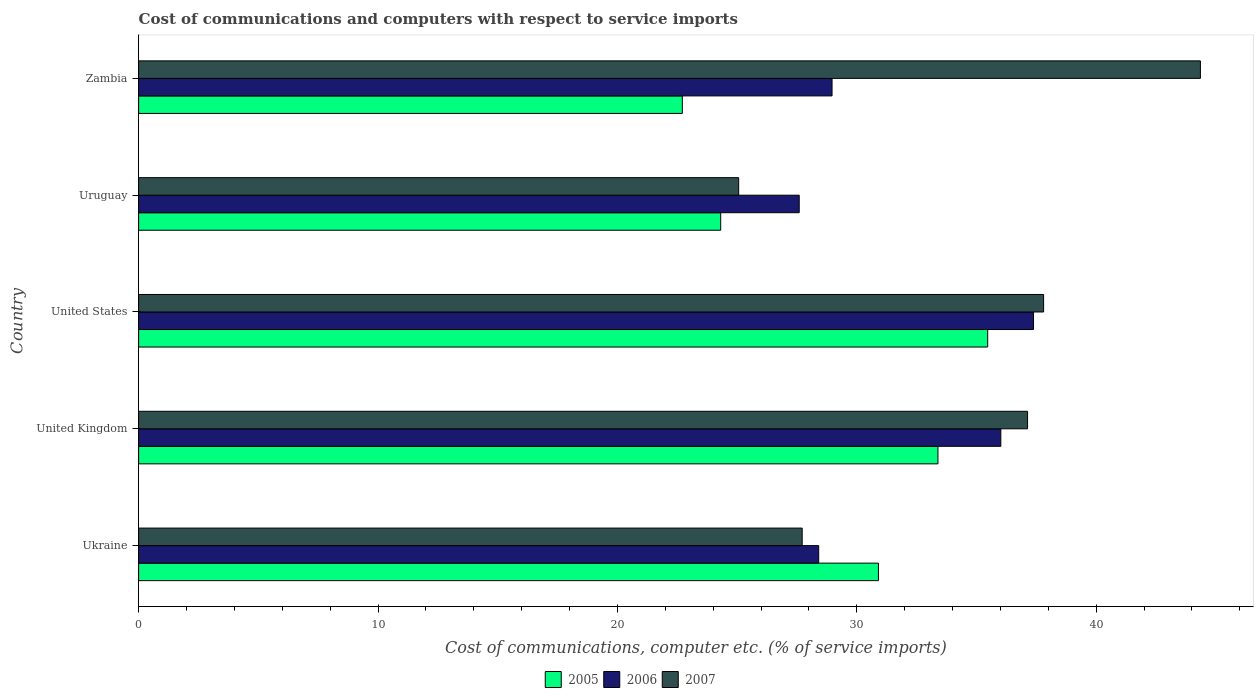Are the number of bars per tick equal to the number of legend labels?
Your response must be concise. Yes. Are the number of bars on each tick of the Y-axis equal?
Ensure brevity in your answer.  Yes. How many bars are there on the 3rd tick from the top?
Provide a succinct answer. 3. How many bars are there on the 1st tick from the bottom?
Your answer should be very brief. 3. What is the label of the 1st group of bars from the top?
Offer a terse response. Zambia. In how many cases, is the number of bars for a given country not equal to the number of legend labels?
Provide a short and direct response. 0. What is the cost of communications and computers in 2006 in United Kingdom?
Make the answer very short. 36.02. Across all countries, what is the maximum cost of communications and computers in 2005?
Offer a terse response. 35.47. Across all countries, what is the minimum cost of communications and computers in 2006?
Your response must be concise. 27.6. In which country was the cost of communications and computers in 2007 maximum?
Your response must be concise. Zambia. In which country was the cost of communications and computers in 2007 minimum?
Offer a terse response. Uruguay. What is the total cost of communications and computers in 2007 in the graph?
Your answer should be compact. 172.08. What is the difference between the cost of communications and computers in 2005 in United Kingdom and that in Zambia?
Provide a succinct answer. 10.68. What is the difference between the cost of communications and computers in 2005 in United Kingdom and the cost of communications and computers in 2006 in Ukraine?
Your answer should be compact. 4.98. What is the average cost of communications and computers in 2007 per country?
Your response must be concise. 34.42. What is the difference between the cost of communications and computers in 2007 and cost of communications and computers in 2006 in United States?
Ensure brevity in your answer.  0.42. What is the ratio of the cost of communications and computers in 2006 in United States to that in Zambia?
Make the answer very short. 1.29. Is the cost of communications and computers in 2005 in Ukraine less than that in United States?
Keep it short and to the point. Yes. What is the difference between the highest and the second highest cost of communications and computers in 2006?
Your response must be concise. 1.37. What is the difference between the highest and the lowest cost of communications and computers in 2007?
Provide a short and direct response. 19.29. In how many countries, is the cost of communications and computers in 2007 greater than the average cost of communications and computers in 2007 taken over all countries?
Offer a terse response. 3. What does the 1st bar from the top in Zambia represents?
Your answer should be compact. 2007. What does the 2nd bar from the bottom in Uruguay represents?
Your answer should be very brief. 2006. How many bars are there?
Make the answer very short. 15. Are all the bars in the graph horizontal?
Your answer should be very brief. Yes. What is the difference between two consecutive major ticks on the X-axis?
Your answer should be compact. 10. Does the graph contain any zero values?
Keep it short and to the point. No. Does the graph contain grids?
Your response must be concise. No. How are the legend labels stacked?
Keep it short and to the point. Horizontal. What is the title of the graph?
Provide a short and direct response. Cost of communications and computers with respect to service imports. What is the label or title of the X-axis?
Make the answer very short. Cost of communications, computer etc. (% of service imports). What is the Cost of communications, computer etc. (% of service imports) in 2005 in Ukraine?
Provide a succinct answer. 30.9. What is the Cost of communications, computer etc. (% of service imports) in 2006 in Ukraine?
Ensure brevity in your answer.  28.41. What is the Cost of communications, computer etc. (% of service imports) in 2007 in Ukraine?
Offer a very short reply. 27.72. What is the Cost of communications, computer etc. (% of service imports) in 2005 in United Kingdom?
Keep it short and to the point. 33.39. What is the Cost of communications, computer etc. (% of service imports) in 2006 in United Kingdom?
Your response must be concise. 36.02. What is the Cost of communications, computer etc. (% of service imports) in 2007 in United Kingdom?
Offer a terse response. 37.13. What is the Cost of communications, computer etc. (% of service imports) of 2005 in United States?
Make the answer very short. 35.47. What is the Cost of communications, computer etc. (% of service imports) of 2006 in United States?
Your answer should be compact. 37.38. What is the Cost of communications, computer etc. (% of service imports) of 2007 in United States?
Your answer should be very brief. 37.8. What is the Cost of communications, computer etc. (% of service imports) in 2005 in Uruguay?
Your response must be concise. 24.32. What is the Cost of communications, computer etc. (% of service imports) of 2006 in Uruguay?
Your answer should be very brief. 27.6. What is the Cost of communications, computer etc. (% of service imports) of 2007 in Uruguay?
Your response must be concise. 25.07. What is the Cost of communications, computer etc. (% of service imports) in 2005 in Zambia?
Provide a short and direct response. 22.71. What is the Cost of communications, computer etc. (% of service imports) of 2006 in Zambia?
Offer a terse response. 28.97. What is the Cost of communications, computer etc. (% of service imports) in 2007 in Zambia?
Your response must be concise. 44.35. Across all countries, what is the maximum Cost of communications, computer etc. (% of service imports) of 2005?
Provide a short and direct response. 35.47. Across all countries, what is the maximum Cost of communications, computer etc. (% of service imports) in 2006?
Offer a very short reply. 37.38. Across all countries, what is the maximum Cost of communications, computer etc. (% of service imports) of 2007?
Give a very brief answer. 44.35. Across all countries, what is the minimum Cost of communications, computer etc. (% of service imports) of 2005?
Your response must be concise. 22.71. Across all countries, what is the minimum Cost of communications, computer etc. (% of service imports) of 2006?
Provide a short and direct response. 27.6. Across all countries, what is the minimum Cost of communications, computer etc. (% of service imports) in 2007?
Your answer should be compact. 25.07. What is the total Cost of communications, computer etc. (% of service imports) in 2005 in the graph?
Your answer should be very brief. 146.79. What is the total Cost of communications, computer etc. (% of service imports) in 2006 in the graph?
Your answer should be compact. 158.37. What is the total Cost of communications, computer etc. (% of service imports) in 2007 in the graph?
Your answer should be compact. 172.08. What is the difference between the Cost of communications, computer etc. (% of service imports) of 2005 in Ukraine and that in United Kingdom?
Offer a very short reply. -2.49. What is the difference between the Cost of communications, computer etc. (% of service imports) of 2006 in Ukraine and that in United Kingdom?
Your response must be concise. -7.61. What is the difference between the Cost of communications, computer etc. (% of service imports) of 2007 in Ukraine and that in United Kingdom?
Your response must be concise. -9.41. What is the difference between the Cost of communications, computer etc. (% of service imports) in 2005 in Ukraine and that in United States?
Keep it short and to the point. -4.56. What is the difference between the Cost of communications, computer etc. (% of service imports) of 2006 in Ukraine and that in United States?
Your response must be concise. -8.97. What is the difference between the Cost of communications, computer etc. (% of service imports) in 2007 in Ukraine and that in United States?
Offer a very short reply. -10.09. What is the difference between the Cost of communications, computer etc. (% of service imports) of 2005 in Ukraine and that in Uruguay?
Provide a succinct answer. 6.59. What is the difference between the Cost of communications, computer etc. (% of service imports) of 2006 in Ukraine and that in Uruguay?
Provide a short and direct response. 0.81. What is the difference between the Cost of communications, computer etc. (% of service imports) of 2007 in Ukraine and that in Uruguay?
Give a very brief answer. 2.65. What is the difference between the Cost of communications, computer etc. (% of service imports) in 2005 in Ukraine and that in Zambia?
Offer a very short reply. 8.19. What is the difference between the Cost of communications, computer etc. (% of service imports) in 2006 in Ukraine and that in Zambia?
Make the answer very short. -0.56. What is the difference between the Cost of communications, computer etc. (% of service imports) in 2007 in Ukraine and that in Zambia?
Offer a terse response. -16.64. What is the difference between the Cost of communications, computer etc. (% of service imports) in 2005 in United Kingdom and that in United States?
Ensure brevity in your answer.  -2.08. What is the difference between the Cost of communications, computer etc. (% of service imports) of 2006 in United Kingdom and that in United States?
Provide a short and direct response. -1.37. What is the difference between the Cost of communications, computer etc. (% of service imports) of 2007 in United Kingdom and that in United States?
Offer a very short reply. -0.67. What is the difference between the Cost of communications, computer etc. (% of service imports) of 2005 in United Kingdom and that in Uruguay?
Offer a very short reply. 9.08. What is the difference between the Cost of communications, computer etc. (% of service imports) in 2006 in United Kingdom and that in Uruguay?
Your answer should be very brief. 8.42. What is the difference between the Cost of communications, computer etc. (% of service imports) of 2007 in United Kingdom and that in Uruguay?
Ensure brevity in your answer.  12.07. What is the difference between the Cost of communications, computer etc. (% of service imports) of 2005 in United Kingdom and that in Zambia?
Offer a very short reply. 10.68. What is the difference between the Cost of communications, computer etc. (% of service imports) of 2006 in United Kingdom and that in Zambia?
Ensure brevity in your answer.  7.05. What is the difference between the Cost of communications, computer etc. (% of service imports) of 2007 in United Kingdom and that in Zambia?
Your answer should be compact. -7.22. What is the difference between the Cost of communications, computer etc. (% of service imports) of 2005 in United States and that in Uruguay?
Your answer should be very brief. 11.15. What is the difference between the Cost of communications, computer etc. (% of service imports) of 2006 in United States and that in Uruguay?
Keep it short and to the point. 9.79. What is the difference between the Cost of communications, computer etc. (% of service imports) of 2007 in United States and that in Uruguay?
Provide a succinct answer. 12.74. What is the difference between the Cost of communications, computer etc. (% of service imports) in 2005 in United States and that in Zambia?
Your answer should be compact. 12.76. What is the difference between the Cost of communications, computer etc. (% of service imports) of 2006 in United States and that in Zambia?
Make the answer very short. 8.42. What is the difference between the Cost of communications, computer etc. (% of service imports) of 2007 in United States and that in Zambia?
Offer a terse response. -6.55. What is the difference between the Cost of communications, computer etc. (% of service imports) of 2005 in Uruguay and that in Zambia?
Provide a short and direct response. 1.6. What is the difference between the Cost of communications, computer etc. (% of service imports) in 2006 in Uruguay and that in Zambia?
Your response must be concise. -1.37. What is the difference between the Cost of communications, computer etc. (% of service imports) of 2007 in Uruguay and that in Zambia?
Provide a short and direct response. -19.29. What is the difference between the Cost of communications, computer etc. (% of service imports) in 2005 in Ukraine and the Cost of communications, computer etc. (% of service imports) in 2006 in United Kingdom?
Your answer should be compact. -5.11. What is the difference between the Cost of communications, computer etc. (% of service imports) in 2005 in Ukraine and the Cost of communications, computer etc. (% of service imports) in 2007 in United Kingdom?
Make the answer very short. -6.23. What is the difference between the Cost of communications, computer etc. (% of service imports) in 2006 in Ukraine and the Cost of communications, computer etc. (% of service imports) in 2007 in United Kingdom?
Offer a terse response. -8.72. What is the difference between the Cost of communications, computer etc. (% of service imports) of 2005 in Ukraine and the Cost of communications, computer etc. (% of service imports) of 2006 in United States?
Ensure brevity in your answer.  -6.48. What is the difference between the Cost of communications, computer etc. (% of service imports) in 2005 in Ukraine and the Cost of communications, computer etc. (% of service imports) in 2007 in United States?
Keep it short and to the point. -6.9. What is the difference between the Cost of communications, computer etc. (% of service imports) of 2006 in Ukraine and the Cost of communications, computer etc. (% of service imports) of 2007 in United States?
Provide a short and direct response. -9.4. What is the difference between the Cost of communications, computer etc. (% of service imports) of 2005 in Ukraine and the Cost of communications, computer etc. (% of service imports) of 2006 in Uruguay?
Ensure brevity in your answer.  3.31. What is the difference between the Cost of communications, computer etc. (% of service imports) in 2005 in Ukraine and the Cost of communications, computer etc. (% of service imports) in 2007 in Uruguay?
Keep it short and to the point. 5.84. What is the difference between the Cost of communications, computer etc. (% of service imports) of 2006 in Ukraine and the Cost of communications, computer etc. (% of service imports) of 2007 in Uruguay?
Make the answer very short. 3.34. What is the difference between the Cost of communications, computer etc. (% of service imports) in 2005 in Ukraine and the Cost of communications, computer etc. (% of service imports) in 2006 in Zambia?
Provide a short and direct response. 1.94. What is the difference between the Cost of communications, computer etc. (% of service imports) of 2005 in Ukraine and the Cost of communications, computer etc. (% of service imports) of 2007 in Zambia?
Provide a succinct answer. -13.45. What is the difference between the Cost of communications, computer etc. (% of service imports) in 2006 in Ukraine and the Cost of communications, computer etc. (% of service imports) in 2007 in Zambia?
Provide a short and direct response. -15.95. What is the difference between the Cost of communications, computer etc. (% of service imports) of 2005 in United Kingdom and the Cost of communications, computer etc. (% of service imports) of 2006 in United States?
Provide a succinct answer. -3.99. What is the difference between the Cost of communications, computer etc. (% of service imports) in 2005 in United Kingdom and the Cost of communications, computer etc. (% of service imports) in 2007 in United States?
Ensure brevity in your answer.  -4.41. What is the difference between the Cost of communications, computer etc. (% of service imports) in 2006 in United Kingdom and the Cost of communications, computer etc. (% of service imports) in 2007 in United States?
Keep it short and to the point. -1.79. What is the difference between the Cost of communications, computer etc. (% of service imports) of 2005 in United Kingdom and the Cost of communications, computer etc. (% of service imports) of 2006 in Uruguay?
Ensure brevity in your answer.  5.79. What is the difference between the Cost of communications, computer etc. (% of service imports) in 2005 in United Kingdom and the Cost of communications, computer etc. (% of service imports) in 2007 in Uruguay?
Your answer should be compact. 8.32. What is the difference between the Cost of communications, computer etc. (% of service imports) in 2006 in United Kingdom and the Cost of communications, computer etc. (% of service imports) in 2007 in Uruguay?
Keep it short and to the point. 10.95. What is the difference between the Cost of communications, computer etc. (% of service imports) in 2005 in United Kingdom and the Cost of communications, computer etc. (% of service imports) in 2006 in Zambia?
Provide a succinct answer. 4.42. What is the difference between the Cost of communications, computer etc. (% of service imports) in 2005 in United Kingdom and the Cost of communications, computer etc. (% of service imports) in 2007 in Zambia?
Give a very brief answer. -10.96. What is the difference between the Cost of communications, computer etc. (% of service imports) of 2006 in United Kingdom and the Cost of communications, computer etc. (% of service imports) of 2007 in Zambia?
Offer a very short reply. -8.34. What is the difference between the Cost of communications, computer etc. (% of service imports) in 2005 in United States and the Cost of communications, computer etc. (% of service imports) in 2006 in Uruguay?
Ensure brevity in your answer.  7.87. What is the difference between the Cost of communications, computer etc. (% of service imports) of 2005 in United States and the Cost of communications, computer etc. (% of service imports) of 2007 in Uruguay?
Give a very brief answer. 10.4. What is the difference between the Cost of communications, computer etc. (% of service imports) of 2006 in United States and the Cost of communications, computer etc. (% of service imports) of 2007 in Uruguay?
Keep it short and to the point. 12.32. What is the difference between the Cost of communications, computer etc. (% of service imports) of 2005 in United States and the Cost of communications, computer etc. (% of service imports) of 2006 in Zambia?
Your response must be concise. 6.5. What is the difference between the Cost of communications, computer etc. (% of service imports) in 2005 in United States and the Cost of communications, computer etc. (% of service imports) in 2007 in Zambia?
Offer a terse response. -8.89. What is the difference between the Cost of communications, computer etc. (% of service imports) in 2006 in United States and the Cost of communications, computer etc. (% of service imports) in 2007 in Zambia?
Offer a terse response. -6.97. What is the difference between the Cost of communications, computer etc. (% of service imports) of 2005 in Uruguay and the Cost of communications, computer etc. (% of service imports) of 2006 in Zambia?
Your response must be concise. -4.65. What is the difference between the Cost of communications, computer etc. (% of service imports) in 2005 in Uruguay and the Cost of communications, computer etc. (% of service imports) in 2007 in Zambia?
Your response must be concise. -20.04. What is the difference between the Cost of communications, computer etc. (% of service imports) in 2006 in Uruguay and the Cost of communications, computer etc. (% of service imports) in 2007 in Zambia?
Your answer should be compact. -16.76. What is the average Cost of communications, computer etc. (% of service imports) of 2005 per country?
Ensure brevity in your answer.  29.36. What is the average Cost of communications, computer etc. (% of service imports) of 2006 per country?
Your answer should be compact. 31.67. What is the average Cost of communications, computer etc. (% of service imports) of 2007 per country?
Give a very brief answer. 34.42. What is the difference between the Cost of communications, computer etc. (% of service imports) of 2005 and Cost of communications, computer etc. (% of service imports) of 2006 in Ukraine?
Provide a short and direct response. 2.5. What is the difference between the Cost of communications, computer etc. (% of service imports) of 2005 and Cost of communications, computer etc. (% of service imports) of 2007 in Ukraine?
Keep it short and to the point. 3.19. What is the difference between the Cost of communications, computer etc. (% of service imports) of 2006 and Cost of communications, computer etc. (% of service imports) of 2007 in Ukraine?
Offer a very short reply. 0.69. What is the difference between the Cost of communications, computer etc. (% of service imports) in 2005 and Cost of communications, computer etc. (% of service imports) in 2006 in United Kingdom?
Make the answer very short. -2.63. What is the difference between the Cost of communications, computer etc. (% of service imports) in 2005 and Cost of communications, computer etc. (% of service imports) in 2007 in United Kingdom?
Your answer should be very brief. -3.74. What is the difference between the Cost of communications, computer etc. (% of service imports) in 2006 and Cost of communications, computer etc. (% of service imports) in 2007 in United Kingdom?
Provide a short and direct response. -1.12. What is the difference between the Cost of communications, computer etc. (% of service imports) in 2005 and Cost of communications, computer etc. (% of service imports) in 2006 in United States?
Provide a short and direct response. -1.91. What is the difference between the Cost of communications, computer etc. (% of service imports) of 2005 and Cost of communications, computer etc. (% of service imports) of 2007 in United States?
Your answer should be compact. -2.34. What is the difference between the Cost of communications, computer etc. (% of service imports) in 2006 and Cost of communications, computer etc. (% of service imports) in 2007 in United States?
Your answer should be very brief. -0.42. What is the difference between the Cost of communications, computer etc. (% of service imports) of 2005 and Cost of communications, computer etc. (% of service imports) of 2006 in Uruguay?
Give a very brief answer. -3.28. What is the difference between the Cost of communications, computer etc. (% of service imports) in 2005 and Cost of communications, computer etc. (% of service imports) in 2007 in Uruguay?
Give a very brief answer. -0.75. What is the difference between the Cost of communications, computer etc. (% of service imports) of 2006 and Cost of communications, computer etc. (% of service imports) of 2007 in Uruguay?
Ensure brevity in your answer.  2.53. What is the difference between the Cost of communications, computer etc. (% of service imports) in 2005 and Cost of communications, computer etc. (% of service imports) in 2006 in Zambia?
Ensure brevity in your answer.  -6.25. What is the difference between the Cost of communications, computer etc. (% of service imports) of 2005 and Cost of communications, computer etc. (% of service imports) of 2007 in Zambia?
Your answer should be very brief. -21.64. What is the difference between the Cost of communications, computer etc. (% of service imports) in 2006 and Cost of communications, computer etc. (% of service imports) in 2007 in Zambia?
Ensure brevity in your answer.  -15.39. What is the ratio of the Cost of communications, computer etc. (% of service imports) in 2005 in Ukraine to that in United Kingdom?
Your answer should be very brief. 0.93. What is the ratio of the Cost of communications, computer etc. (% of service imports) of 2006 in Ukraine to that in United Kingdom?
Provide a short and direct response. 0.79. What is the ratio of the Cost of communications, computer etc. (% of service imports) in 2007 in Ukraine to that in United Kingdom?
Your answer should be very brief. 0.75. What is the ratio of the Cost of communications, computer etc. (% of service imports) in 2005 in Ukraine to that in United States?
Give a very brief answer. 0.87. What is the ratio of the Cost of communications, computer etc. (% of service imports) in 2006 in Ukraine to that in United States?
Your answer should be compact. 0.76. What is the ratio of the Cost of communications, computer etc. (% of service imports) in 2007 in Ukraine to that in United States?
Provide a short and direct response. 0.73. What is the ratio of the Cost of communications, computer etc. (% of service imports) in 2005 in Ukraine to that in Uruguay?
Keep it short and to the point. 1.27. What is the ratio of the Cost of communications, computer etc. (% of service imports) of 2006 in Ukraine to that in Uruguay?
Make the answer very short. 1.03. What is the ratio of the Cost of communications, computer etc. (% of service imports) in 2007 in Ukraine to that in Uruguay?
Provide a succinct answer. 1.11. What is the ratio of the Cost of communications, computer etc. (% of service imports) of 2005 in Ukraine to that in Zambia?
Your answer should be very brief. 1.36. What is the ratio of the Cost of communications, computer etc. (% of service imports) in 2006 in Ukraine to that in Zambia?
Your answer should be very brief. 0.98. What is the ratio of the Cost of communications, computer etc. (% of service imports) of 2007 in Ukraine to that in Zambia?
Ensure brevity in your answer.  0.62. What is the ratio of the Cost of communications, computer etc. (% of service imports) of 2005 in United Kingdom to that in United States?
Provide a short and direct response. 0.94. What is the ratio of the Cost of communications, computer etc. (% of service imports) of 2006 in United Kingdom to that in United States?
Provide a short and direct response. 0.96. What is the ratio of the Cost of communications, computer etc. (% of service imports) of 2007 in United Kingdom to that in United States?
Give a very brief answer. 0.98. What is the ratio of the Cost of communications, computer etc. (% of service imports) of 2005 in United Kingdom to that in Uruguay?
Your answer should be compact. 1.37. What is the ratio of the Cost of communications, computer etc. (% of service imports) of 2006 in United Kingdom to that in Uruguay?
Keep it short and to the point. 1.31. What is the ratio of the Cost of communications, computer etc. (% of service imports) of 2007 in United Kingdom to that in Uruguay?
Give a very brief answer. 1.48. What is the ratio of the Cost of communications, computer etc. (% of service imports) of 2005 in United Kingdom to that in Zambia?
Offer a very short reply. 1.47. What is the ratio of the Cost of communications, computer etc. (% of service imports) in 2006 in United Kingdom to that in Zambia?
Ensure brevity in your answer.  1.24. What is the ratio of the Cost of communications, computer etc. (% of service imports) of 2007 in United Kingdom to that in Zambia?
Your response must be concise. 0.84. What is the ratio of the Cost of communications, computer etc. (% of service imports) of 2005 in United States to that in Uruguay?
Your answer should be compact. 1.46. What is the ratio of the Cost of communications, computer etc. (% of service imports) in 2006 in United States to that in Uruguay?
Your answer should be compact. 1.35. What is the ratio of the Cost of communications, computer etc. (% of service imports) of 2007 in United States to that in Uruguay?
Ensure brevity in your answer.  1.51. What is the ratio of the Cost of communications, computer etc. (% of service imports) in 2005 in United States to that in Zambia?
Keep it short and to the point. 1.56. What is the ratio of the Cost of communications, computer etc. (% of service imports) in 2006 in United States to that in Zambia?
Provide a short and direct response. 1.29. What is the ratio of the Cost of communications, computer etc. (% of service imports) in 2007 in United States to that in Zambia?
Provide a short and direct response. 0.85. What is the ratio of the Cost of communications, computer etc. (% of service imports) of 2005 in Uruguay to that in Zambia?
Give a very brief answer. 1.07. What is the ratio of the Cost of communications, computer etc. (% of service imports) of 2006 in Uruguay to that in Zambia?
Provide a succinct answer. 0.95. What is the ratio of the Cost of communications, computer etc. (% of service imports) in 2007 in Uruguay to that in Zambia?
Ensure brevity in your answer.  0.57. What is the difference between the highest and the second highest Cost of communications, computer etc. (% of service imports) in 2005?
Offer a very short reply. 2.08. What is the difference between the highest and the second highest Cost of communications, computer etc. (% of service imports) in 2006?
Offer a very short reply. 1.37. What is the difference between the highest and the second highest Cost of communications, computer etc. (% of service imports) of 2007?
Give a very brief answer. 6.55. What is the difference between the highest and the lowest Cost of communications, computer etc. (% of service imports) of 2005?
Keep it short and to the point. 12.76. What is the difference between the highest and the lowest Cost of communications, computer etc. (% of service imports) in 2006?
Provide a short and direct response. 9.79. What is the difference between the highest and the lowest Cost of communications, computer etc. (% of service imports) of 2007?
Keep it short and to the point. 19.29. 